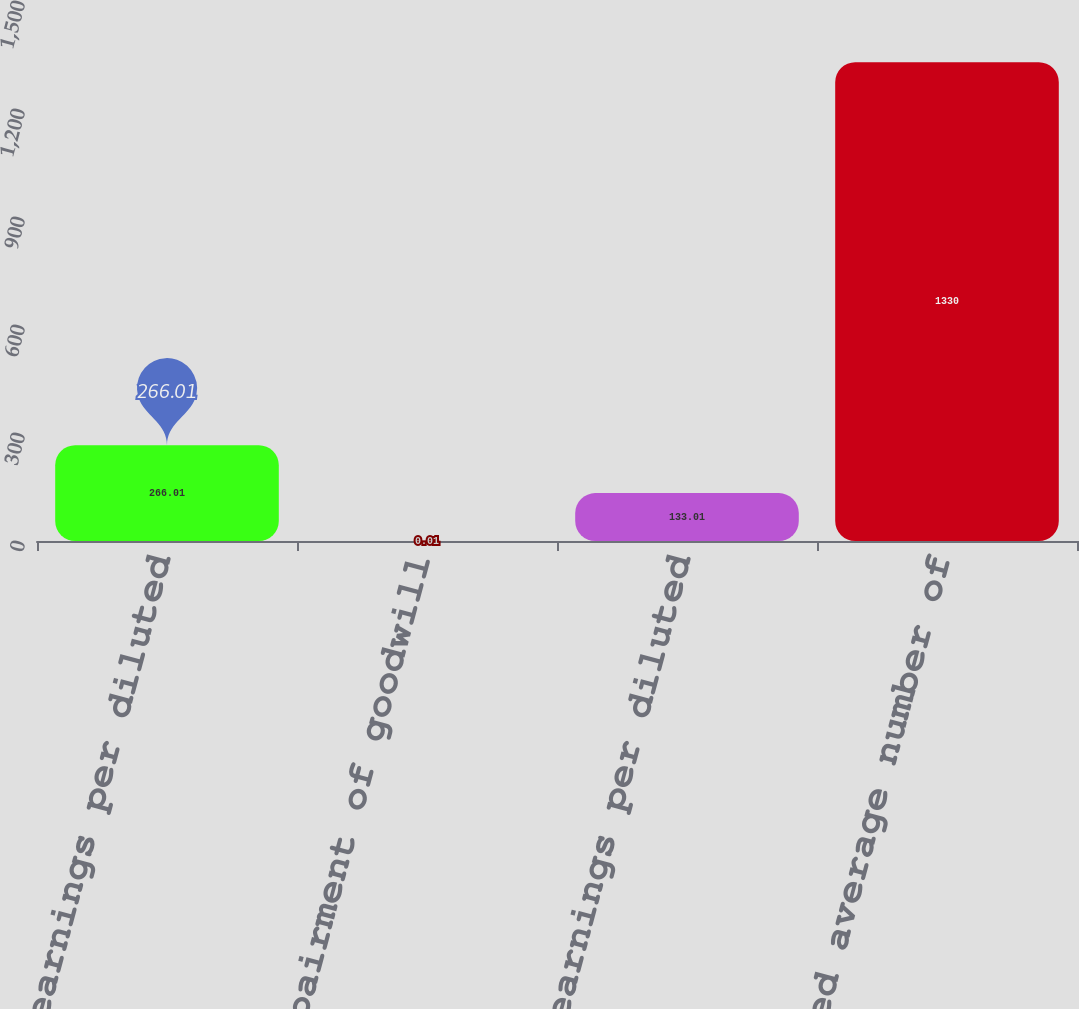Convert chart to OTSL. <chart><loc_0><loc_0><loc_500><loc_500><bar_chart><fcel>Reported earnings per diluted<fcel>Impairment of goodwill<fcel>Non-GAAP earnings per diluted<fcel>Weighted average number of<nl><fcel>266.01<fcel>0.01<fcel>133.01<fcel>1330<nl></chart> 